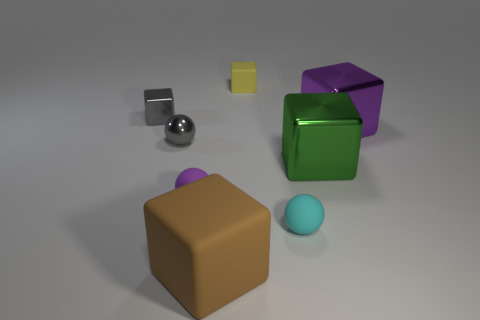Is the small shiny block the same color as the small metal sphere?
Make the answer very short. Yes. What is the material of the cube that is the same color as the metal sphere?
Offer a very short reply. Metal. Does the small metallic object that is behind the large purple cube have the same color as the tiny metallic object that is in front of the big purple shiny block?
Your answer should be compact. Yes. Is there anything else that has the same size as the yellow object?
Provide a succinct answer. Yes. What size is the gray object that is the same shape as the cyan thing?
Provide a short and direct response. Small. Are there more yellow cubes to the left of the purple rubber ball than green cubes that are behind the purple metal thing?
Your answer should be very brief. No. Is the green cube made of the same material as the small gray thing that is left of the small gray sphere?
Keep it short and to the point. Yes. Is there anything else that is the same shape as the big purple object?
Your response must be concise. Yes. There is a metal thing that is both behind the gray ball and to the right of the gray metal ball; what color is it?
Keep it short and to the point. Purple. There is a purple object on the left side of the big rubber thing; what is its shape?
Ensure brevity in your answer.  Sphere. 